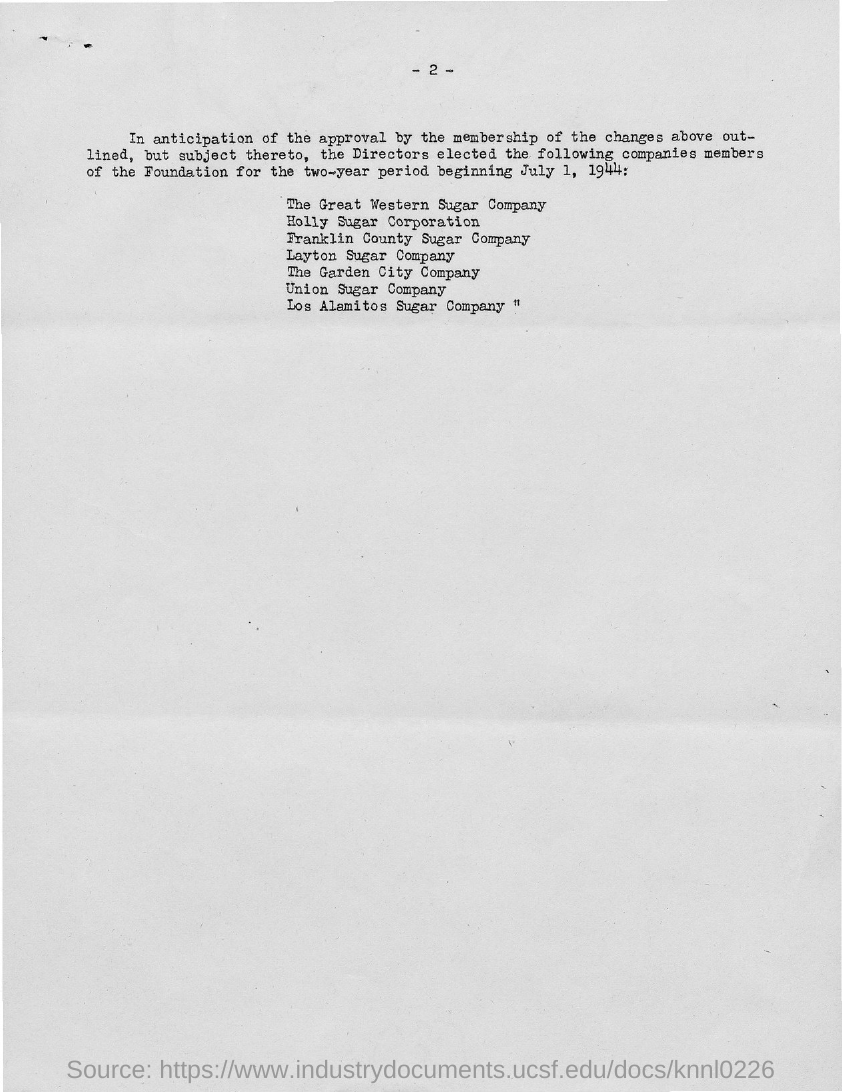What is the page no mentioned in this document?
Your answer should be compact. 2. 